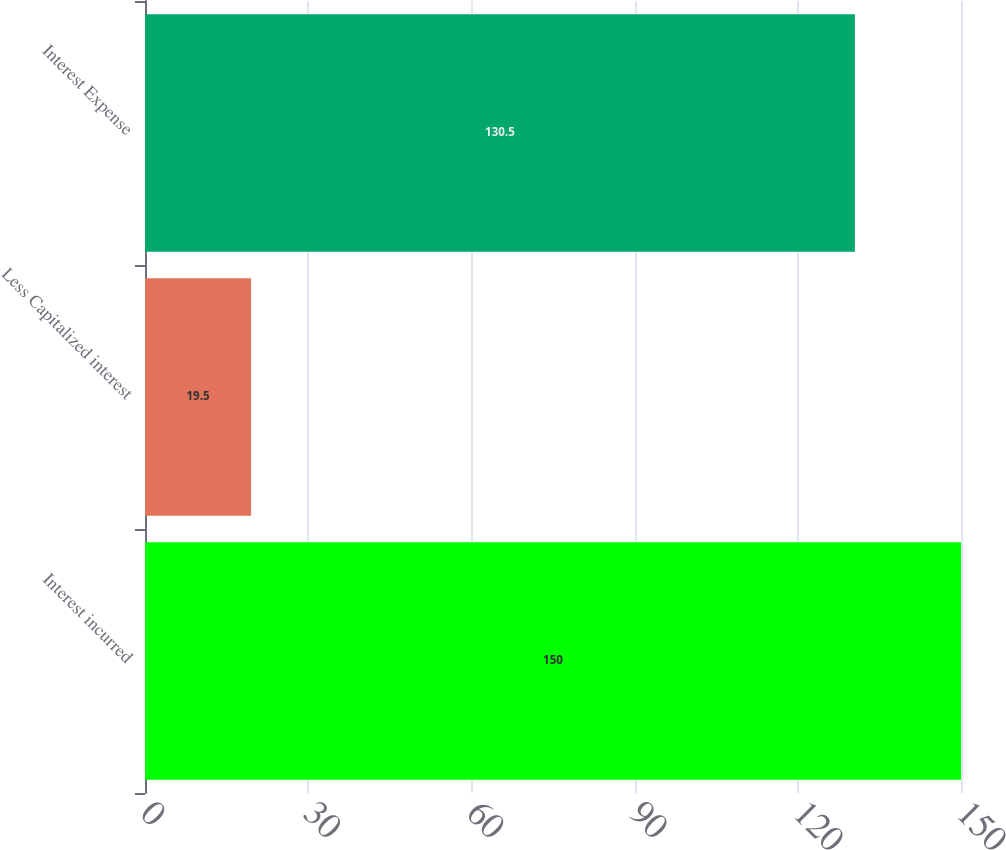Convert chart to OTSL. <chart><loc_0><loc_0><loc_500><loc_500><bar_chart><fcel>Interest incurred<fcel>Less Capitalized interest<fcel>Interest Expense<nl><fcel>150<fcel>19.5<fcel>130.5<nl></chart> 